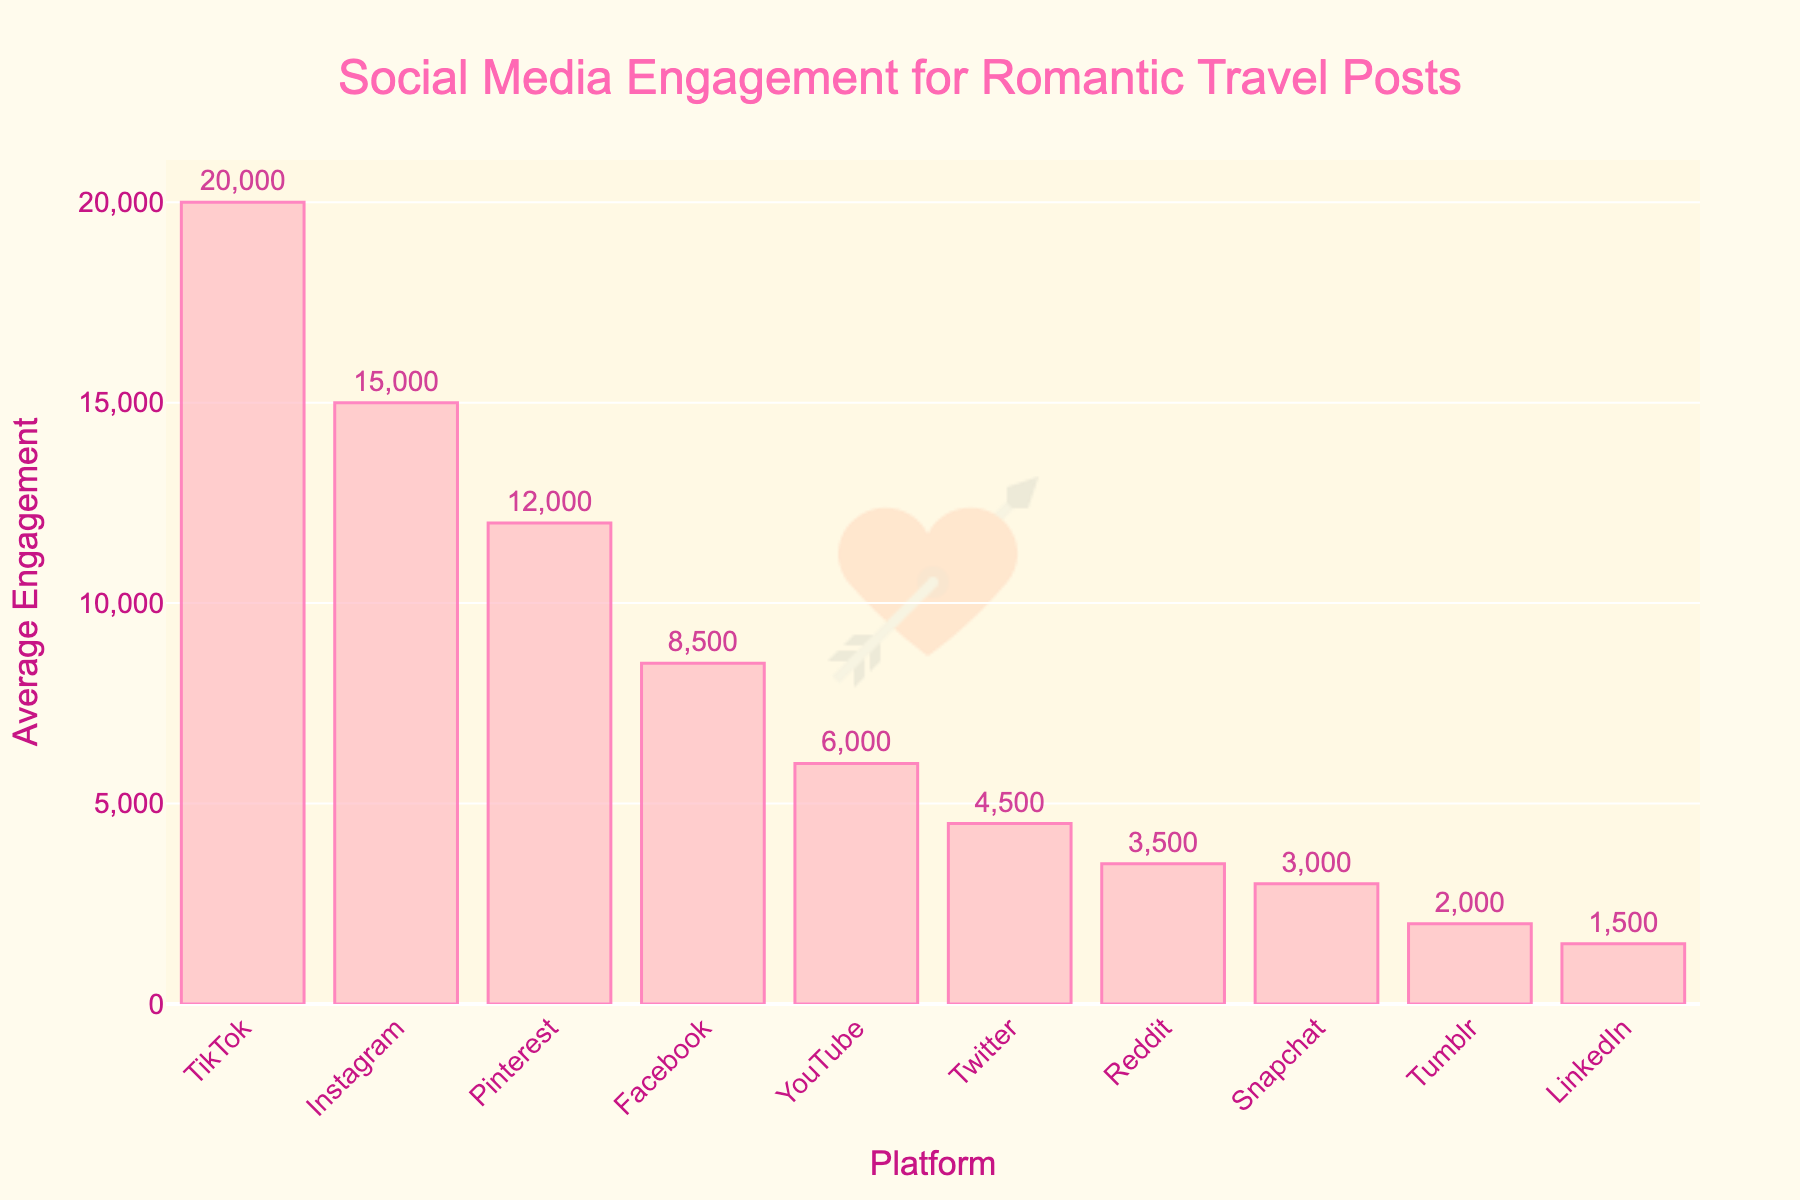What's the platform with the highest average engagement? The platform with the highest average engagement is determined by the tallest bar in the chart. TikTok has the tallest bar, indicating the highest average engagement.
Answer: TikTok Which platform has the least average engagement? To find the platform with the least average engagement, we need to look for the shortest bar in the chart. LinkedIn has the shortest bar, indicating the lowest average engagement.
Answer: LinkedIn How much more engagement does TikTok get compared to Twitter? TikTok has an average engagement of 20,000 while Twitter has 4,500. The difference is calculated as 20,000 - 4,500.
Answer: 15,500 What is the total engagement for Instagram, Facebook, and Pinterest combined? Sum the average engagements for Instagram, Facebook, and Pinterest: 15,000 (Instagram) + 8,500 (Facebook) + 12,000 (Pinterest) = 35,500.
Answer: 35,500 What's the average engagement across all platforms shown? First, sum up all the average engagements: 15,000 (Instagram) + 8,500 (Facebook) + 12,000 (Pinterest) + 20,000 (TikTok) + 6,000 (YouTube) + 4,500 (Twitter) + 3,000 (Snapchat) + 1,500 (LinkedIn) + 2,000 (Tumblr) + 3,500 (Reddit) = 76,000. Then, divide by the number of platforms (10): 76,000 / 10 = 7,600.
Answer: 7,600 Which platforms have an average engagement higher than 10,000? Platforms with bars extending higher than the 10,000 mark are Instagram, Pinterest, and TikTok because their average engagements are 15,000, 12,000, and 20,000 respectively.
Answer: Instagram, Pinterest, TikTok Between YouTube and Facebook, which one has a higher engagement, and by how much? YouTube has an average engagement of 6,000, while Facebook has 8,500. The difference is calculated as 8,500 - 6,000.
Answer: Facebook, 2,500 What is the median engagement value of the platforms? To find the median, we need to list the engagements in ascending order: 1,500 (LinkedIn), 2,000 (Tumblr), 3,000 (Snapchat), 3,500 (Reddit), 4,500 (Twitter), 6,000 (YouTube), 8,500 (Facebook), 12,000 (Pinterest), 15,000 (Instagram), 20,000 (TikTok). With 10 values, the median will be the average of the 5th and 6th values: (4,500 + 6,000) / 2 = 5,250.
Answer: 5,250 If we combine the engagements of Instagram, Facebook, and TikTok, does it surpass the sum of the engagements of YouTube, Twitter, and Reddit? Sum the engagements of Instagram, Facebook, and TikTok: 15,000 + 8,500 + 20,000 = 43,500. Then sum the engagements of YouTube, Twitter, and Reddit: 6,000 + 4,500 + 3,500 = 14,000. 43,500 is greater than 14,000.
Answer: Yes How many platforms have engagements below the average engagement (7,600)? Platforms with engagements below 7,600 are YouTube (6,000), Twitter (4,500), Snapchat (3,000), LinkedIn (1,500), Tumblr (2,000), Reddit (3,500). This makes a total of 6 platforms.
Answer: 6 